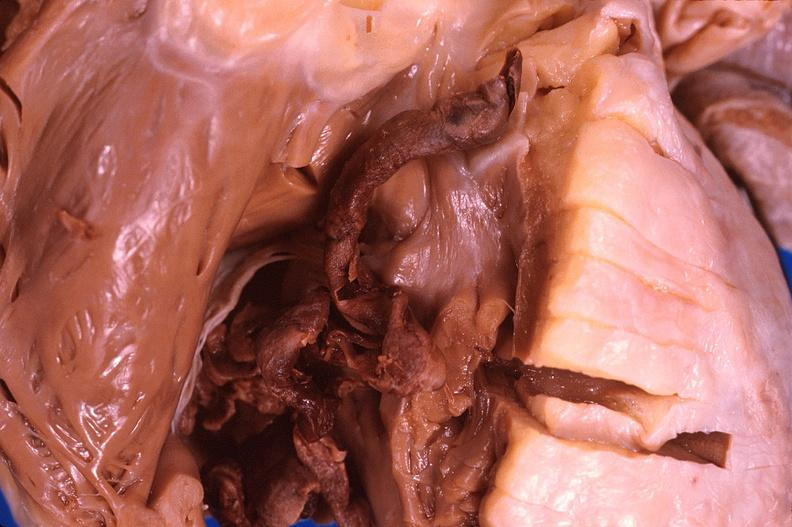what is present?
Answer the question using a single word or phrase. Cardiovascular 